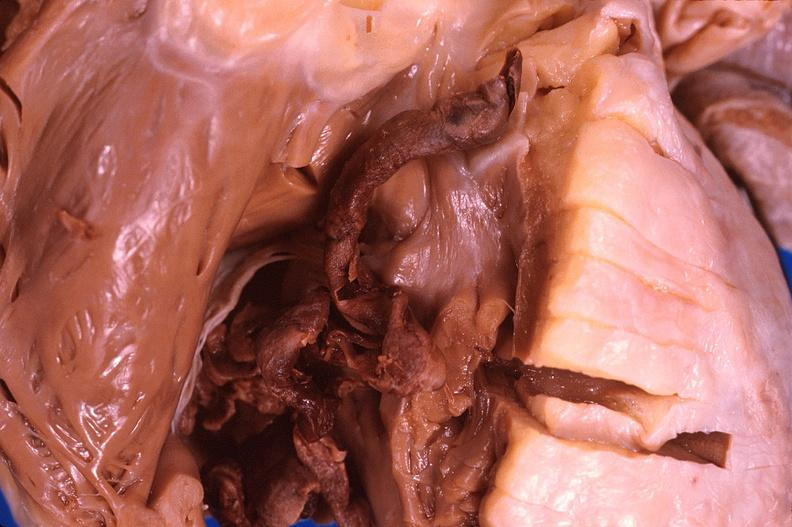what is present?
Answer the question using a single word or phrase. Cardiovascular 